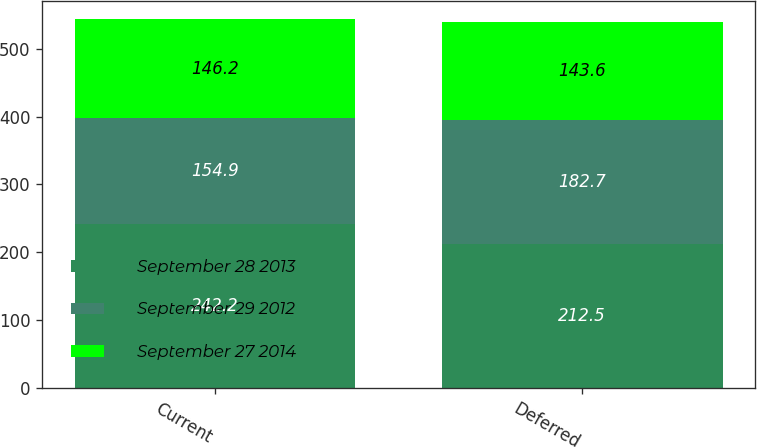Convert chart to OTSL. <chart><loc_0><loc_0><loc_500><loc_500><stacked_bar_chart><ecel><fcel>Current<fcel>Deferred<nl><fcel>September 28 2013<fcel>242.2<fcel>212.5<nl><fcel>September 29 2012<fcel>154.9<fcel>182.7<nl><fcel>September 27 2014<fcel>146.2<fcel>143.6<nl></chart> 